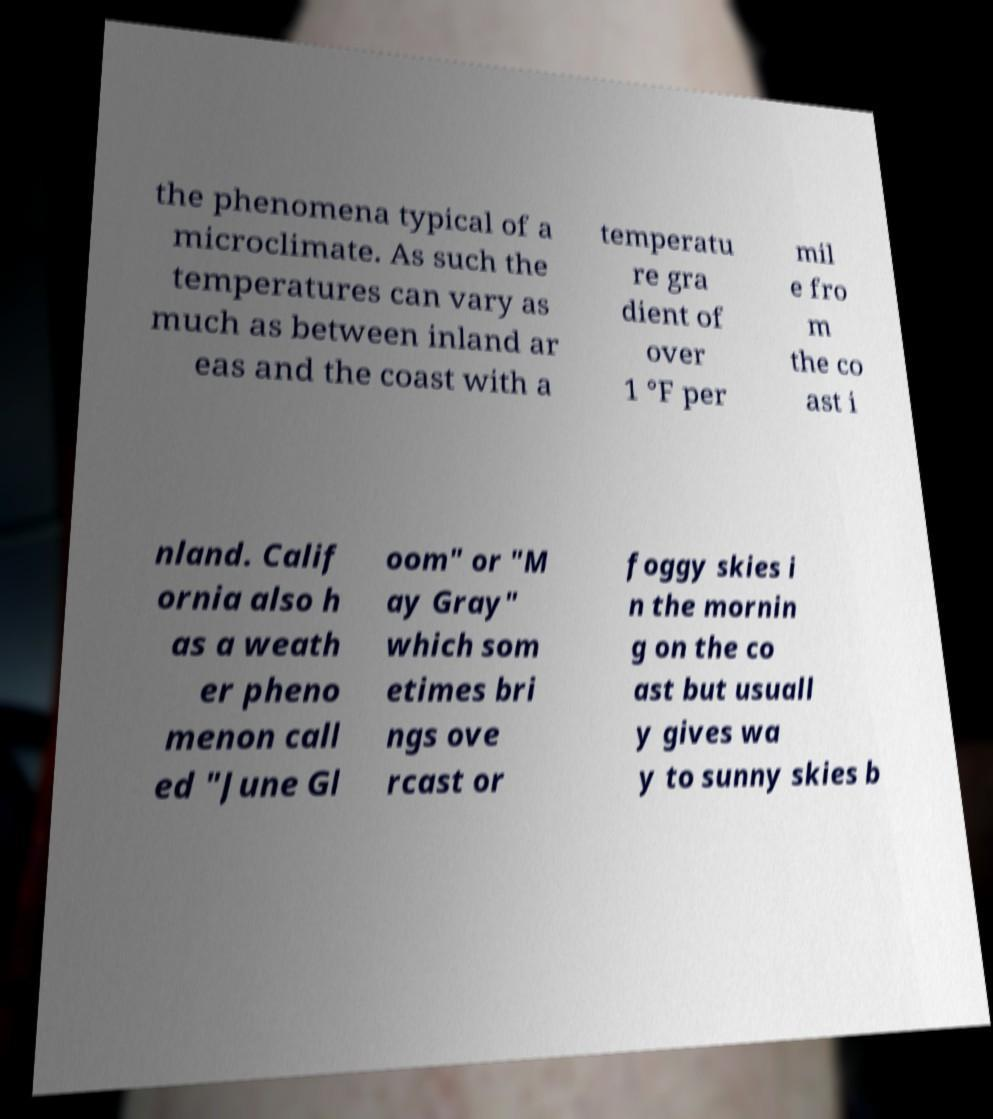What messages or text are displayed in this image? I need them in a readable, typed format. the phenomena typical of a microclimate. As such the temperatures can vary as much as between inland ar eas and the coast with a temperatu re gra dient of over 1 °F per mil e fro m the co ast i nland. Calif ornia also h as a weath er pheno menon call ed "June Gl oom" or "M ay Gray" which som etimes bri ngs ove rcast or foggy skies i n the mornin g on the co ast but usuall y gives wa y to sunny skies b 